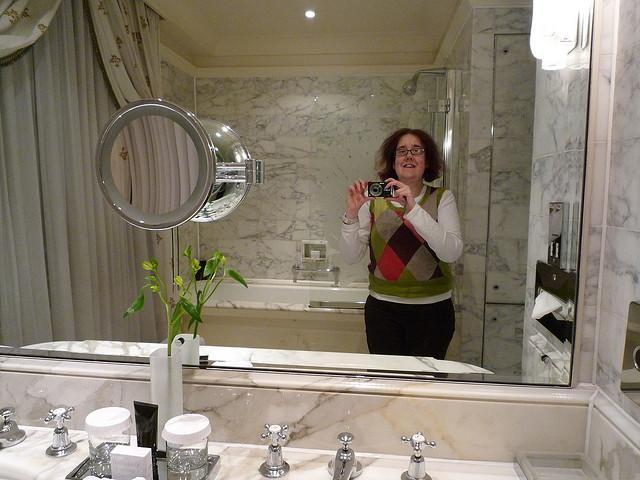What type of shower head is in the background? overhead 